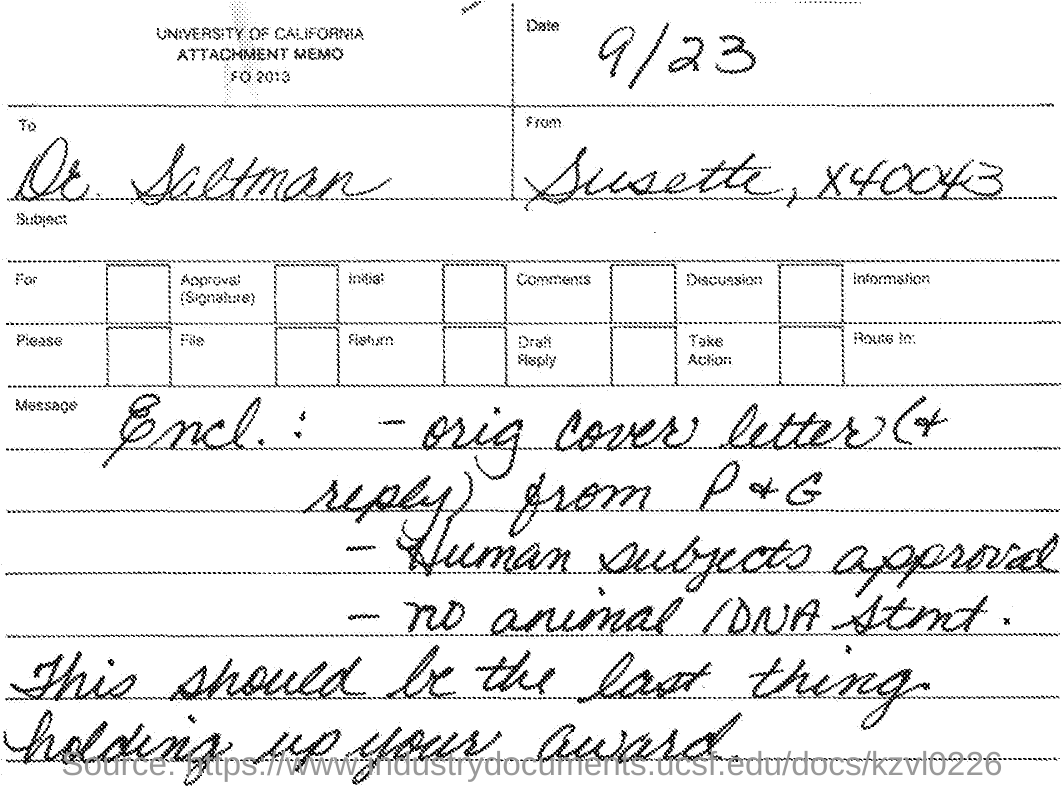Indicate a few pertinent items in this graphic. What is the date mentioned? September 23rd. The University of California is the name of the university mentioned. The recipient of this letter is Dr. Saltman. This letter is sent from Susette. 